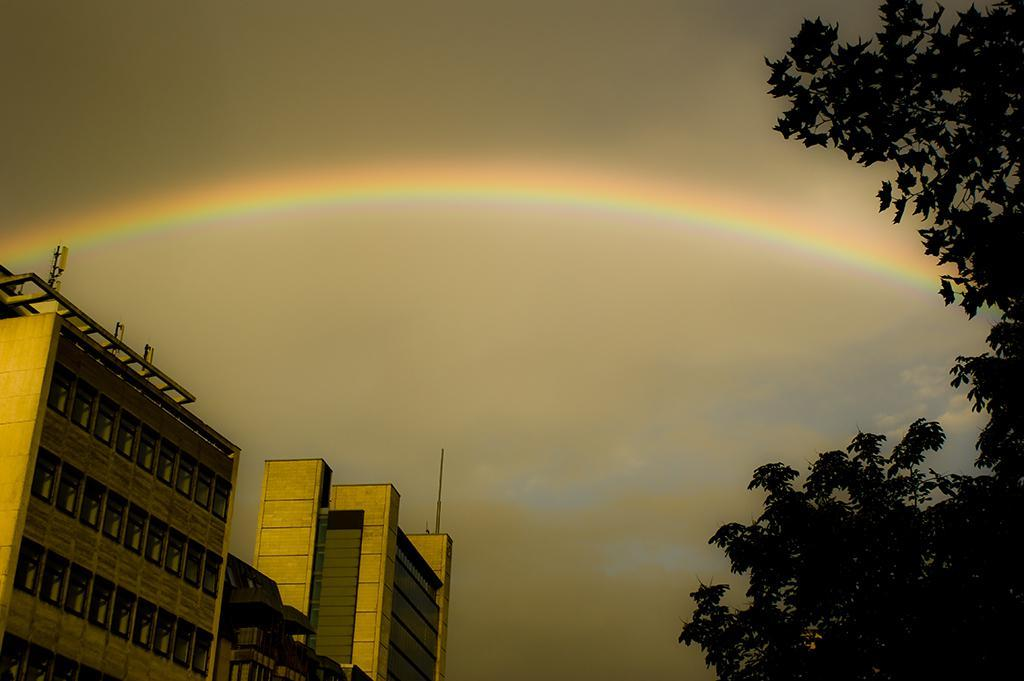What type of vegetation is on the right side of the image? There are trees on the right side of the image. What type of structures are on the left side of the image? There are buildings on the left side of the image. What natural phenomenon can be seen in the sky? There is a rainbow in the sky. What type of care can be seen being provided to the train in the image? There is no train present in the image, so no care is being provided to a train. What type of camera is being used to capture the image? The factual information provided does not mention a camera, so we cannot determine the type of camera used to capture the image. 